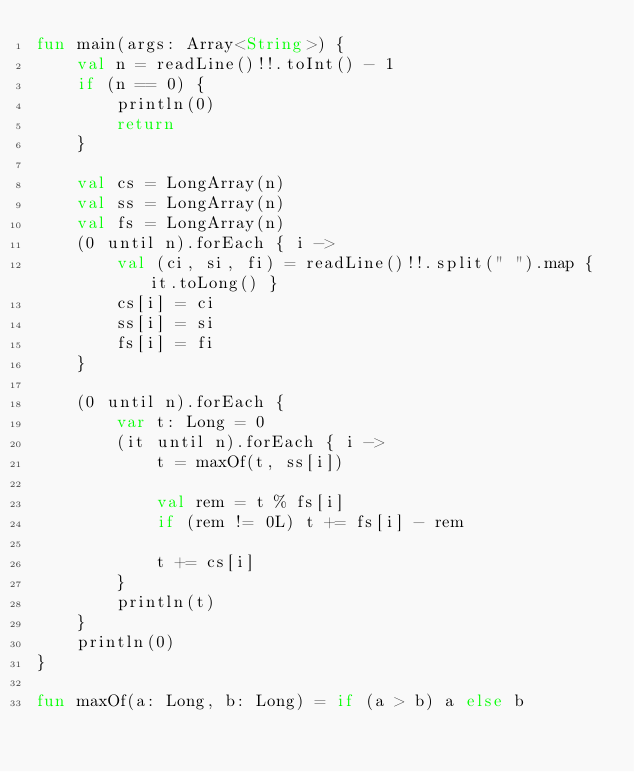Convert code to text. <code><loc_0><loc_0><loc_500><loc_500><_Kotlin_>fun main(args: Array<String>) {
    val n = readLine()!!.toInt() - 1
    if (n == 0) {
        println(0)
        return
    }

    val cs = LongArray(n)
    val ss = LongArray(n)
    val fs = LongArray(n)
    (0 until n).forEach { i ->
        val (ci, si, fi) = readLine()!!.split(" ").map { it.toLong() }
        cs[i] = ci
        ss[i] = si
        fs[i] = fi
    }

    (0 until n).forEach {
        var t: Long = 0
        (it until n).forEach { i ->
            t = maxOf(t, ss[i])

            val rem = t % fs[i]
            if (rem != 0L) t += fs[i] - rem
            
            t += cs[i]
        }
        println(t)
    }
    println(0)
}

fun maxOf(a: Long, b: Long) = if (a > b) a else b</code> 